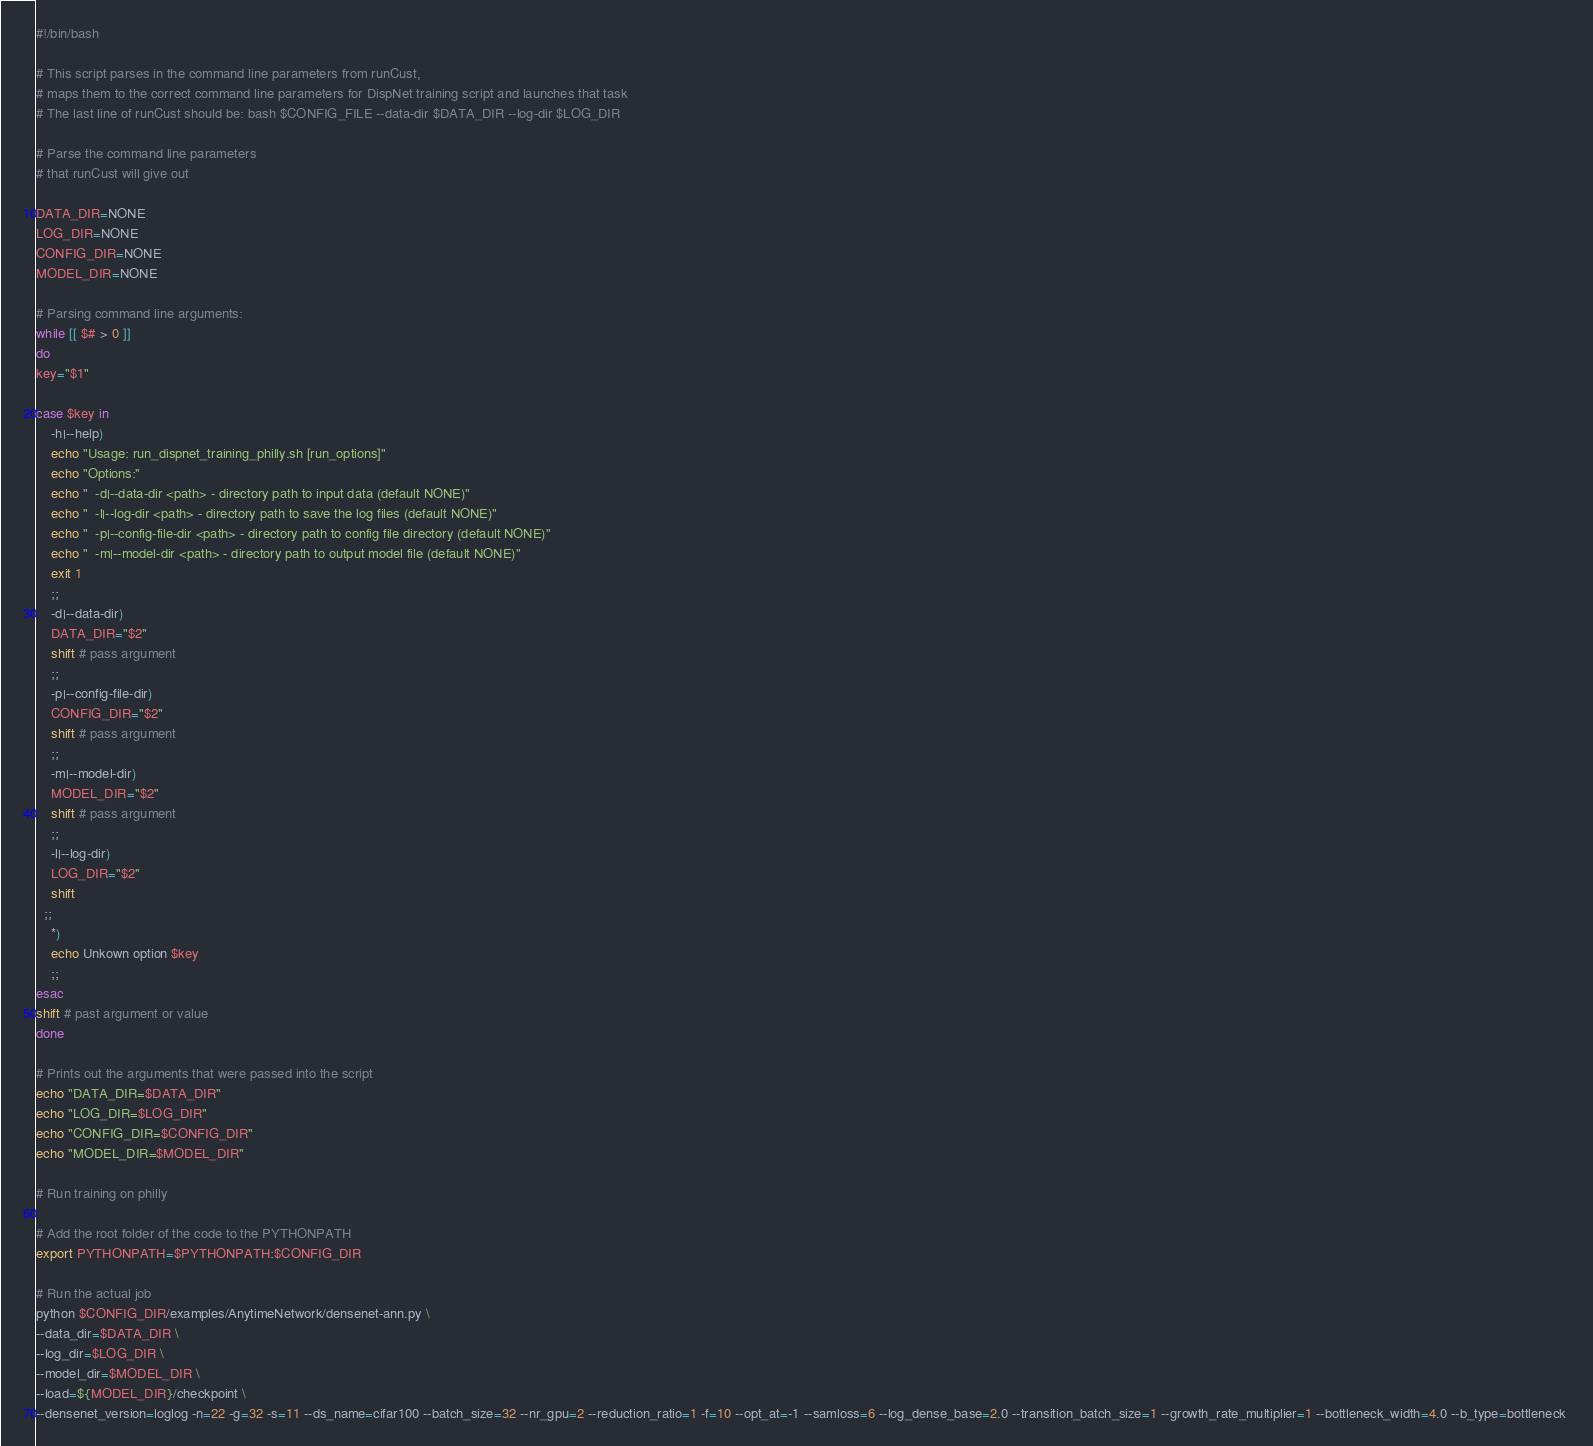Convert code to text. <code><loc_0><loc_0><loc_500><loc_500><_Bash_>#!/bin/bash

# This script parses in the command line parameters from runCust, 
# maps them to the correct command line parameters for DispNet training script and launches that task
# The last line of runCust should be: bash $CONFIG_FILE --data-dir $DATA_DIR --log-dir $LOG_DIR

# Parse the command line parameters
# that runCust will give out

DATA_DIR=NONE
LOG_DIR=NONE
CONFIG_DIR=NONE
MODEL_DIR=NONE

# Parsing command line arguments:
while [[ $# > 0 ]]
do
key="$1"

case $key in
    -h|--help)
    echo "Usage: run_dispnet_training_philly.sh [run_options]"
    echo "Options:"
    echo "  -d|--data-dir <path> - directory path to input data (default NONE)"
    echo "  -l|--log-dir <path> - directory path to save the log files (default NONE)"
    echo "  -p|--config-file-dir <path> - directory path to config file directory (default NONE)"
    echo "  -m|--model-dir <path> - directory path to output model file (default NONE)"
    exit 1
    ;;
    -d|--data-dir)
    DATA_DIR="$2"
    shift # pass argument
    ;;
    -p|--config-file-dir)
    CONFIG_DIR="$2"
    shift # pass argument
    ;;
    -m|--model-dir)
    MODEL_DIR="$2"
    shift # pass argument
    ;;
    -l|--log-dir)
    LOG_DIR="$2"
    shift
  ;;
    *)
    echo Unkown option $key
    ;;
esac
shift # past argument or value
done

# Prints out the arguments that were passed into the script
echo "DATA_DIR=$DATA_DIR"
echo "LOG_DIR=$LOG_DIR"
echo "CONFIG_DIR=$CONFIG_DIR"
echo "MODEL_DIR=$MODEL_DIR"

# Run training on philly

# Add the root folder of the code to the PYTHONPATH
export PYTHONPATH=$PYTHONPATH:$CONFIG_DIR

# Run the actual job
python $CONFIG_DIR/examples/AnytimeNetwork/densenet-ann.py \
--data_dir=$DATA_DIR \
--log_dir=$LOG_DIR \
--model_dir=$MODEL_DIR \
--load=${MODEL_DIR}/checkpoint \
--densenet_version=loglog -n=22 -g=32 -s=11 --ds_name=cifar100 --batch_size=32 --nr_gpu=2 --reduction_ratio=1 -f=10 --opt_at=-1 --samloss=6 --log_dense_base=2.0 --transition_batch_size=1 --growth_rate_multiplier=1 --bottleneck_width=4.0 --b_type=bottleneck 
</code> 